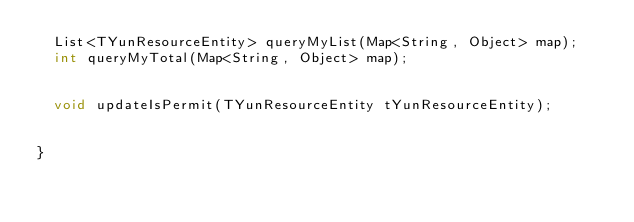<code> <loc_0><loc_0><loc_500><loc_500><_Java_>	List<TYunResourceEntity> queryMyList(Map<String, Object> map);
	int queryMyTotal(Map<String, Object> map);
	
	
	void updateIsPermit(TYunResourceEntity tYunResourceEntity);

	
}
</code> 